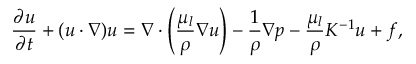<formula> <loc_0><loc_0><loc_500><loc_500>\frac { \partial u } { \partial t } + ( u \cdot \nabla ) u = \nabla \cdot \left ( \frac { \mu _ { l } } { \rho } \nabla u \right ) - \frac { 1 } { \rho } \nabla p - \frac { \mu _ { l } } { \rho } K ^ { - 1 } u + f ,</formula> 